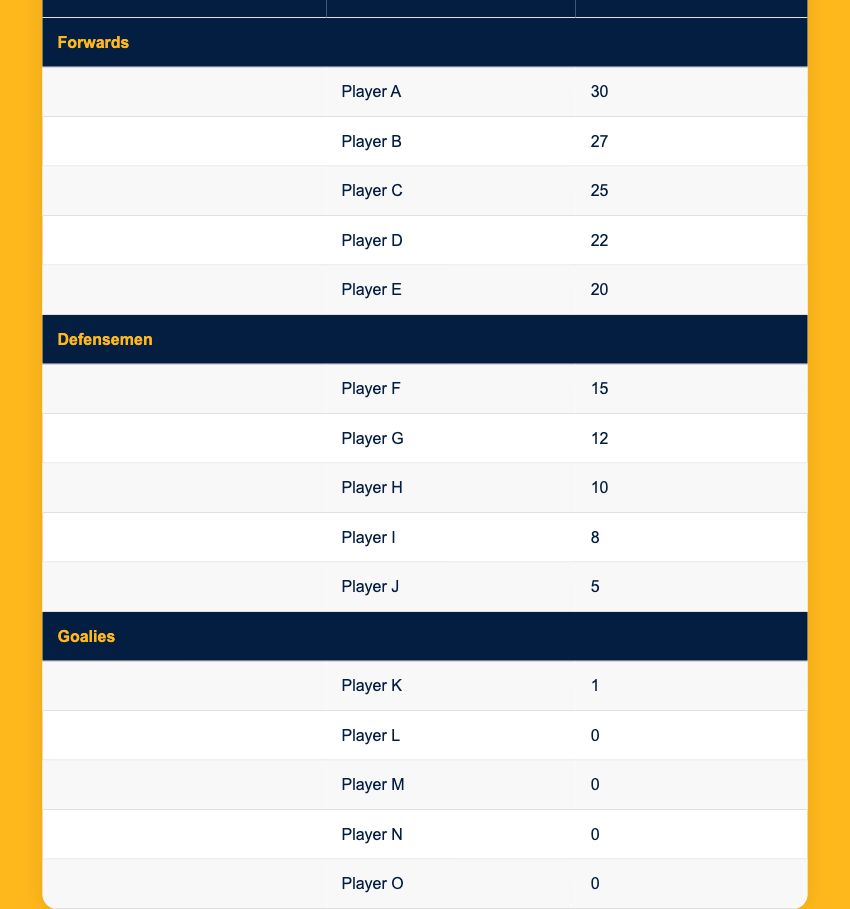What position scored the most goals? By looking at the table, we can see that the forwards have the highest number of goals scored. Player A scored 30 goals, which is more than any other player listed. Therefore, the position that scored the most goals is forwards.
Answer: Forwards What is the total number of goals scored by defensemen? We need to sum the goals scored by all defensemen listed: 15 (Player F) + 12 (Player G) + 10 (Player H) + 8 (Player I) + 5 (Player J) = 50. Therefore, the total number of goals scored by defensemen is 50.
Answer: 50 Did any goalies score more than 0 goals? Looking at the table under the goalies section, only Player K scored 1 goal, while Players L, M, N, and O all scored 0 goals. Therefore, yes, one goalie did score more than 0 goals.
Answer: Yes What is the average number of goals scored by forwards? To find the average, we sum the goals scored by forwards: 30 + 27 + 25 + 22 + 20 = 124. There are 5 forwards, so we divide the total by 5: 124/5 = 24.8. The average number of goals scored by forwards is 24.8.
Answer: 24.8 Which player scored the fewest goals, and how many did they score? By examining the "Goals" column, the minimum value for goals is 0, scored by Players L, M, N, and O (goalies). However, if we consider only the forwards and defensemen, Player J scored the fewest with 5 goals.
Answer: Player J, 5 goals 